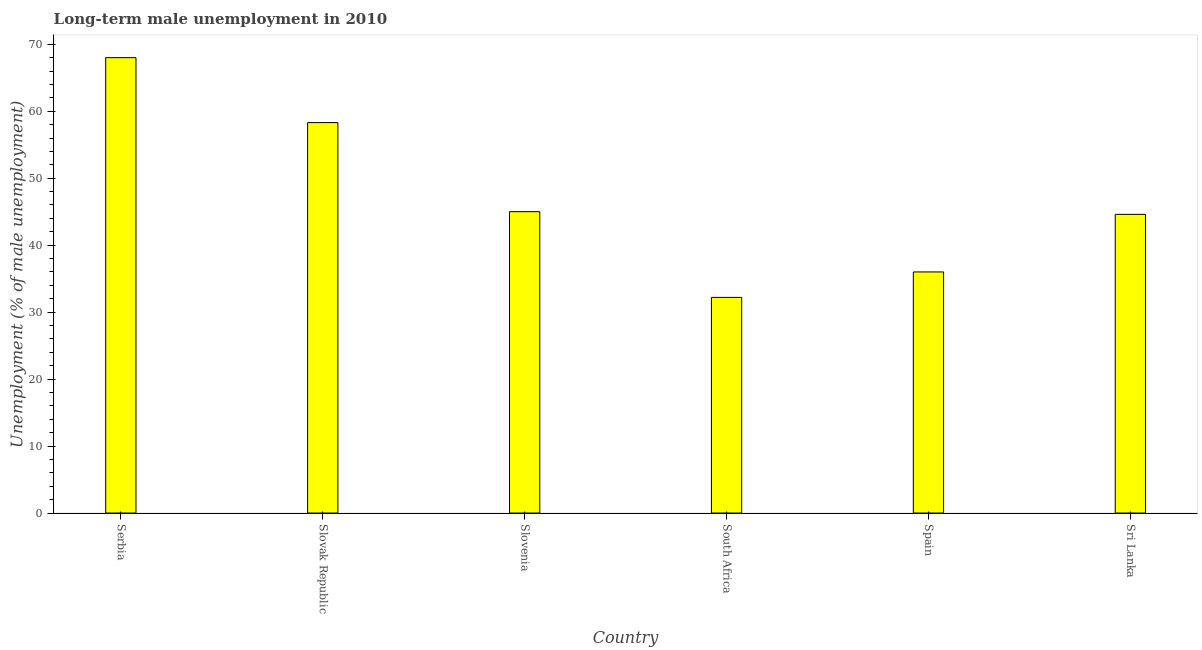What is the title of the graph?
Provide a short and direct response. Long-term male unemployment in 2010. What is the label or title of the Y-axis?
Your answer should be compact. Unemployment (% of male unemployment). What is the long-term male unemployment in Serbia?
Provide a succinct answer. 68. Across all countries, what is the maximum long-term male unemployment?
Offer a very short reply. 68. Across all countries, what is the minimum long-term male unemployment?
Make the answer very short. 32.2. In which country was the long-term male unemployment maximum?
Provide a succinct answer. Serbia. In which country was the long-term male unemployment minimum?
Provide a short and direct response. South Africa. What is the sum of the long-term male unemployment?
Your answer should be compact. 284.1. What is the average long-term male unemployment per country?
Make the answer very short. 47.35. What is the median long-term male unemployment?
Make the answer very short. 44.8. In how many countries, is the long-term male unemployment greater than 32 %?
Give a very brief answer. 6. What is the ratio of the long-term male unemployment in Serbia to that in Slovak Republic?
Your answer should be compact. 1.17. Is the long-term male unemployment in Serbia less than that in South Africa?
Give a very brief answer. No. Is the sum of the long-term male unemployment in Spain and Sri Lanka greater than the maximum long-term male unemployment across all countries?
Offer a very short reply. Yes. What is the difference between the highest and the lowest long-term male unemployment?
Provide a short and direct response. 35.8. How many bars are there?
Offer a terse response. 6. Are all the bars in the graph horizontal?
Give a very brief answer. No. What is the difference between two consecutive major ticks on the Y-axis?
Your answer should be compact. 10. Are the values on the major ticks of Y-axis written in scientific E-notation?
Offer a terse response. No. What is the Unemployment (% of male unemployment) of Serbia?
Your answer should be compact. 68. What is the Unemployment (% of male unemployment) of Slovak Republic?
Offer a terse response. 58.3. What is the Unemployment (% of male unemployment) in South Africa?
Offer a terse response. 32.2. What is the Unemployment (% of male unemployment) in Spain?
Provide a short and direct response. 36. What is the Unemployment (% of male unemployment) of Sri Lanka?
Make the answer very short. 44.6. What is the difference between the Unemployment (% of male unemployment) in Serbia and South Africa?
Give a very brief answer. 35.8. What is the difference between the Unemployment (% of male unemployment) in Serbia and Sri Lanka?
Offer a terse response. 23.4. What is the difference between the Unemployment (% of male unemployment) in Slovak Republic and Slovenia?
Ensure brevity in your answer.  13.3. What is the difference between the Unemployment (% of male unemployment) in Slovak Republic and South Africa?
Make the answer very short. 26.1. What is the difference between the Unemployment (% of male unemployment) in Slovak Republic and Spain?
Make the answer very short. 22.3. What is the difference between the Unemployment (% of male unemployment) in Slovak Republic and Sri Lanka?
Offer a terse response. 13.7. What is the difference between the Unemployment (% of male unemployment) in Slovenia and Spain?
Keep it short and to the point. 9. What is the difference between the Unemployment (% of male unemployment) in Slovenia and Sri Lanka?
Your response must be concise. 0.4. What is the difference between the Unemployment (% of male unemployment) in South Africa and Spain?
Make the answer very short. -3.8. What is the difference between the Unemployment (% of male unemployment) in South Africa and Sri Lanka?
Give a very brief answer. -12.4. What is the ratio of the Unemployment (% of male unemployment) in Serbia to that in Slovak Republic?
Keep it short and to the point. 1.17. What is the ratio of the Unemployment (% of male unemployment) in Serbia to that in Slovenia?
Make the answer very short. 1.51. What is the ratio of the Unemployment (% of male unemployment) in Serbia to that in South Africa?
Make the answer very short. 2.11. What is the ratio of the Unemployment (% of male unemployment) in Serbia to that in Spain?
Your answer should be compact. 1.89. What is the ratio of the Unemployment (% of male unemployment) in Serbia to that in Sri Lanka?
Ensure brevity in your answer.  1.52. What is the ratio of the Unemployment (% of male unemployment) in Slovak Republic to that in Slovenia?
Keep it short and to the point. 1.3. What is the ratio of the Unemployment (% of male unemployment) in Slovak Republic to that in South Africa?
Offer a very short reply. 1.81. What is the ratio of the Unemployment (% of male unemployment) in Slovak Republic to that in Spain?
Make the answer very short. 1.62. What is the ratio of the Unemployment (% of male unemployment) in Slovak Republic to that in Sri Lanka?
Your answer should be compact. 1.31. What is the ratio of the Unemployment (% of male unemployment) in Slovenia to that in South Africa?
Your answer should be compact. 1.4. What is the ratio of the Unemployment (% of male unemployment) in Slovenia to that in Spain?
Provide a short and direct response. 1.25. What is the ratio of the Unemployment (% of male unemployment) in Slovenia to that in Sri Lanka?
Your answer should be compact. 1.01. What is the ratio of the Unemployment (% of male unemployment) in South Africa to that in Spain?
Offer a very short reply. 0.89. What is the ratio of the Unemployment (% of male unemployment) in South Africa to that in Sri Lanka?
Give a very brief answer. 0.72. What is the ratio of the Unemployment (% of male unemployment) in Spain to that in Sri Lanka?
Your response must be concise. 0.81. 